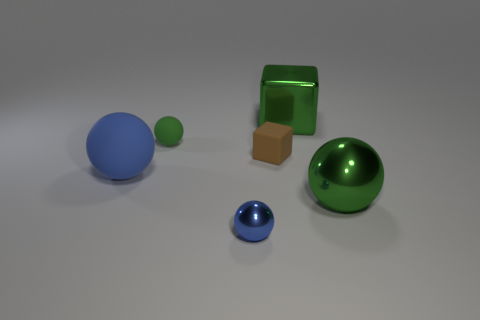Do the green object in front of the blue rubber object and the green matte thing have the same shape?
Your answer should be very brief. Yes. How many blue things are tiny metallic spheres or metal things?
Your response must be concise. 1. Are there more yellow balls than big green shiny balls?
Your answer should be very brief. No. There is another matte object that is the same size as the brown rubber object; what is its color?
Your response must be concise. Green. What number of cylinders are either brown things or green matte things?
Keep it short and to the point. 0. Is the shape of the small brown matte thing the same as the rubber object that is behind the brown thing?
Offer a very short reply. No. What number of yellow shiny cubes have the same size as the green cube?
Provide a short and direct response. 0. There is a big green shiny object behind the large blue rubber sphere; is it the same shape as the blue thing that is in front of the big blue ball?
Ensure brevity in your answer.  No. The tiny metallic object that is the same color as the big matte thing is what shape?
Your response must be concise. Sphere. The metallic thing that is left of the matte object to the right of the green matte ball is what color?
Make the answer very short. Blue. 